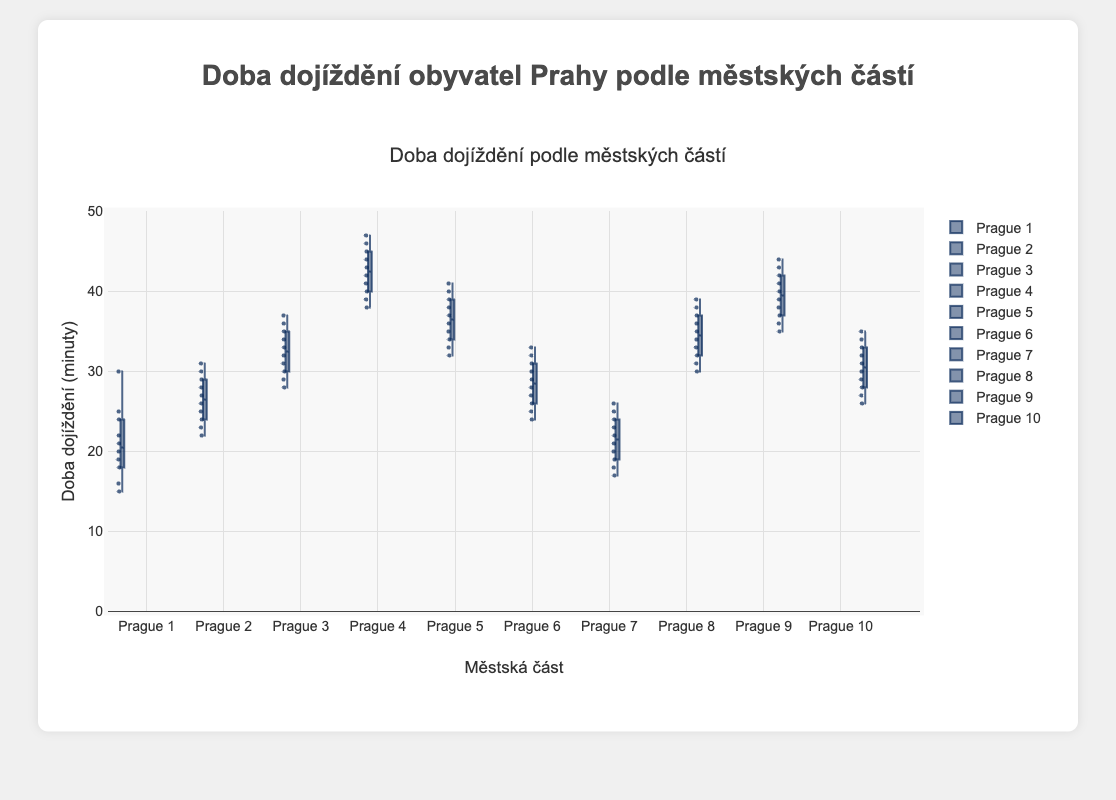Which district has the shortest median commute time? The median commute time can be identified by the line inside each box plot. Among all districts, the line in the box plot for Prague 1 is the lowest, indicating it has the shortest median commute time.
Answer: Prague 1 Which district has the largest range in commute times? The range of commute times is identified by the distance between the minimum and maximum points in each box plot. Prague 4 has the widest spread, from a minimum near 38 minutes to a maximum near 47 minutes, showing the largest range.
Answer: Prague 4 What is the median commute time for Prague 4? The median commute time is indicated by the line inside the box of the box plot. For Prague 4, the median value appears to be at 42 minutes.
Answer: 42 minutes Are the interquartile ranges (IQR) of Prague 3 and Prague 6 different? The IQR is the range between the first quartile (bottom of the box) and the third quartile (top of the box). For Prague 3, the IQR spans from around 29 to 36 minutes. For Prague 6, it spans from about 26 to 31 minutes. So yes, Prague 3 has a larger IQR.
Answer: Yes Which district has the most consistent (least varied) commute times? The consistency in commute times can be seen by the size of the box (IQR) and the overall whisker length. Prague 7 has the smallest box and short whiskers, indicating the least variation in commute times.
Answer: Prague 7 Compare the upper whisker lengths of Prague 5 and Prague 8. Which is longer? The upper whisker represents the spread of the top 25% of the data. In this case, the upper whisker of Prague 8 ends near 39 minutes, while Prague 5's ends near 41 minutes, making Prague 5's upper whisker longer.
Answer: Prague 5 What is the median commute time for Prague 10? The median commute time is shown by the line inside the box plot. For Prague 10, the line is at 30 minutes.
Answer: 30 minutes Which districts have upper whiskers reaching 40 minutes or more? To answer this, we look at the upper whisker of each district’s box plot. Prague 4, Prague 5, Prague 9, and Prague 8 have whiskers reaching 40 minutes or more.
Answer: Prague 4, Prague 5, Prague 9, Prague 8 Identify which districts have overlapping interquartile ranges (IQR). To determine overlapping IQRs, compare the boxes from Q1 to Q3. For example, Prague 2 and Prague 6 have overlapping IQRs since their boxes lie within the range of approximately 22 to 31 minutes. Similarly, Prague 3 and Prague 8 have significant overlap in the range of about 31 to 37 minutes. Prague 5 also overlaps with these ranges.
Answer: Prague 2 & Prague 6, Prague 3 & Prague 8 & Prague 5 